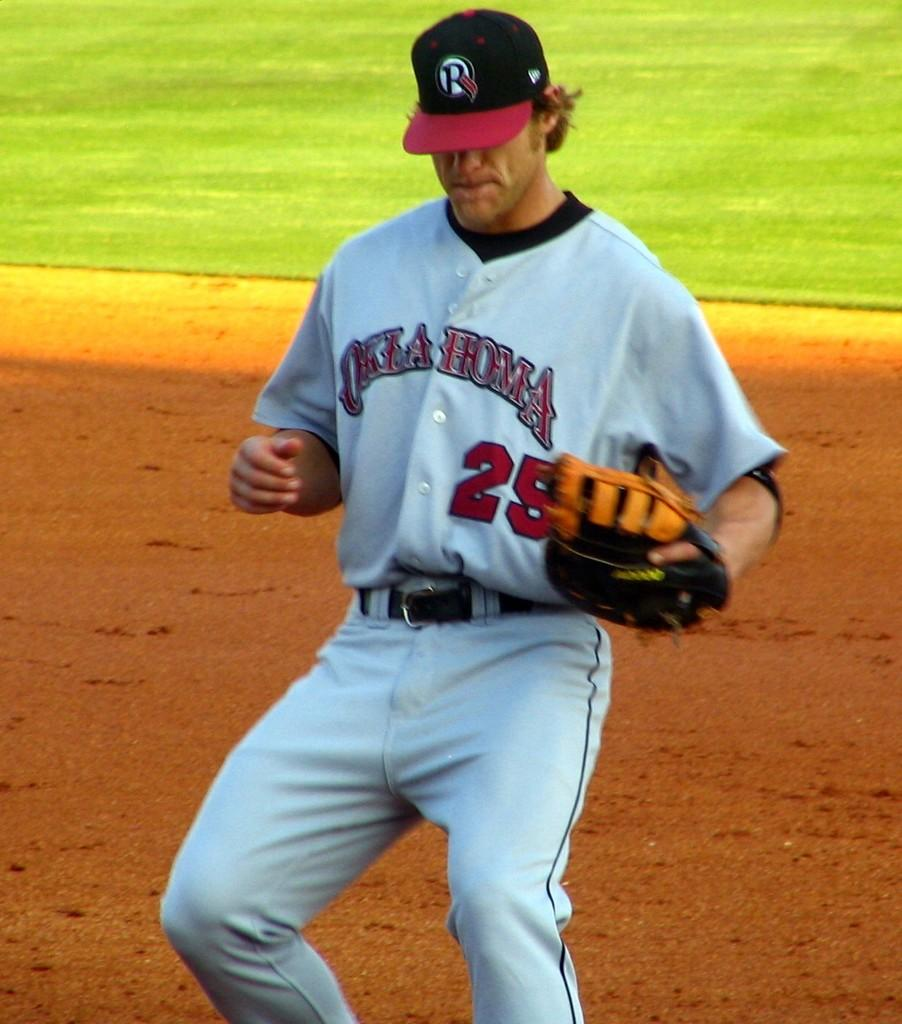Provide a one-sentence caption for the provided image. Oklahoma jersey worn on a player that is playing baseball. 